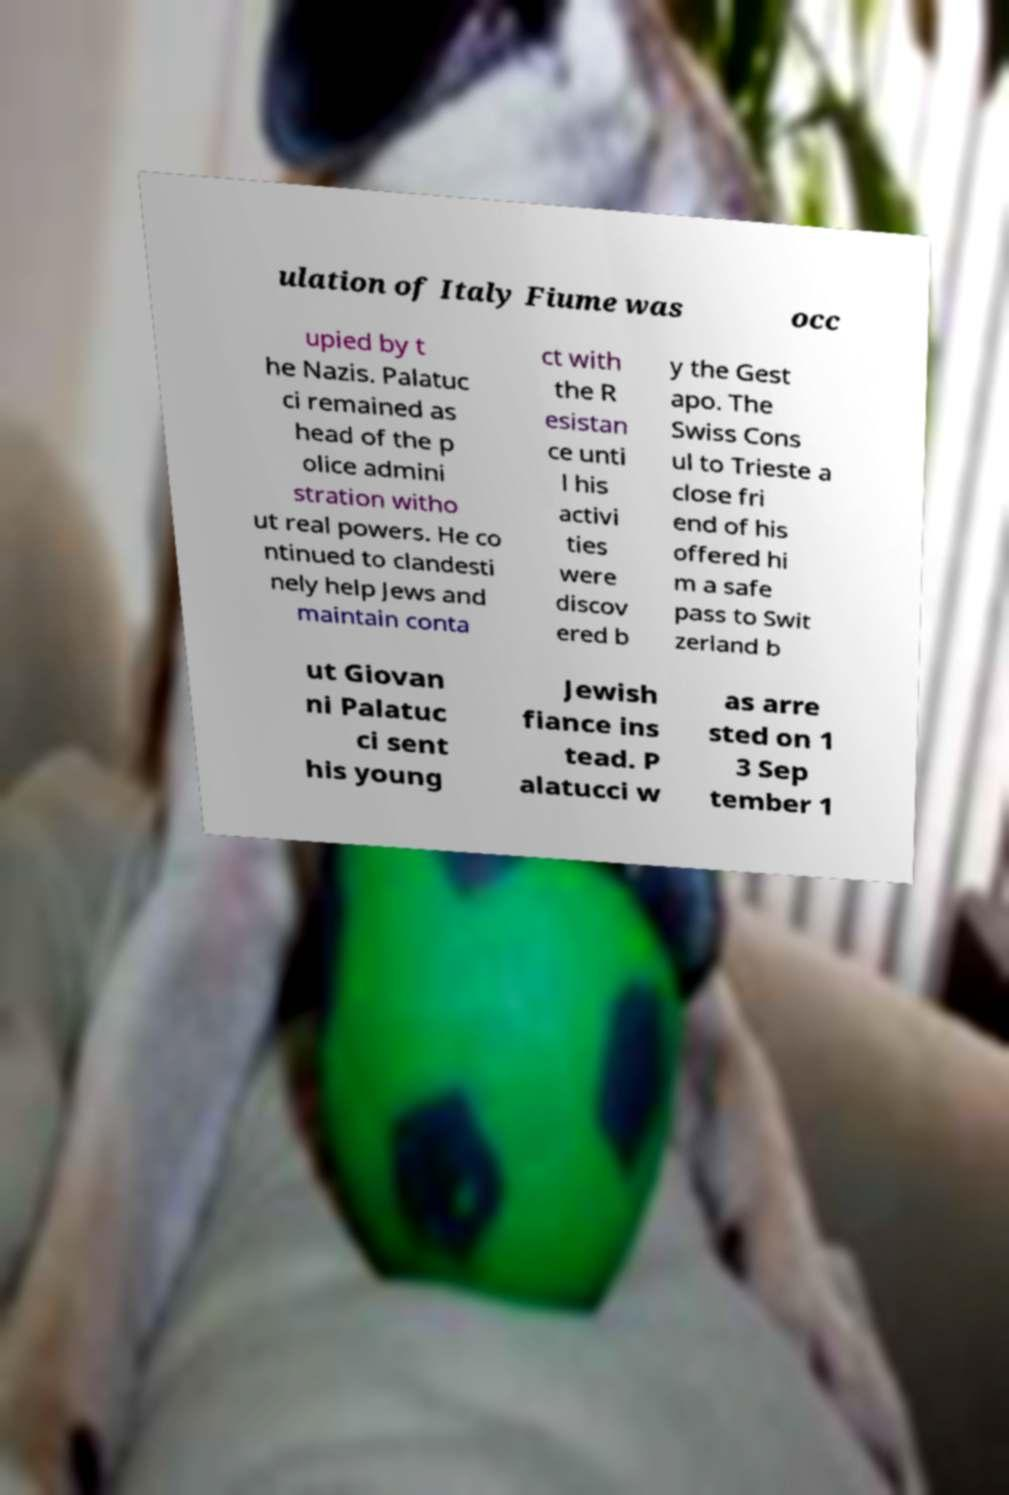Please read and relay the text visible in this image. What does it say? ulation of Italy Fiume was occ upied by t he Nazis. Palatuc ci remained as head of the p olice admini stration witho ut real powers. He co ntinued to clandesti nely help Jews and maintain conta ct with the R esistan ce unti l his activi ties were discov ered b y the Gest apo. The Swiss Cons ul to Trieste a close fri end of his offered hi m a safe pass to Swit zerland b ut Giovan ni Palatuc ci sent his young Jewish fiance ins tead. P alatucci w as arre sted on 1 3 Sep tember 1 